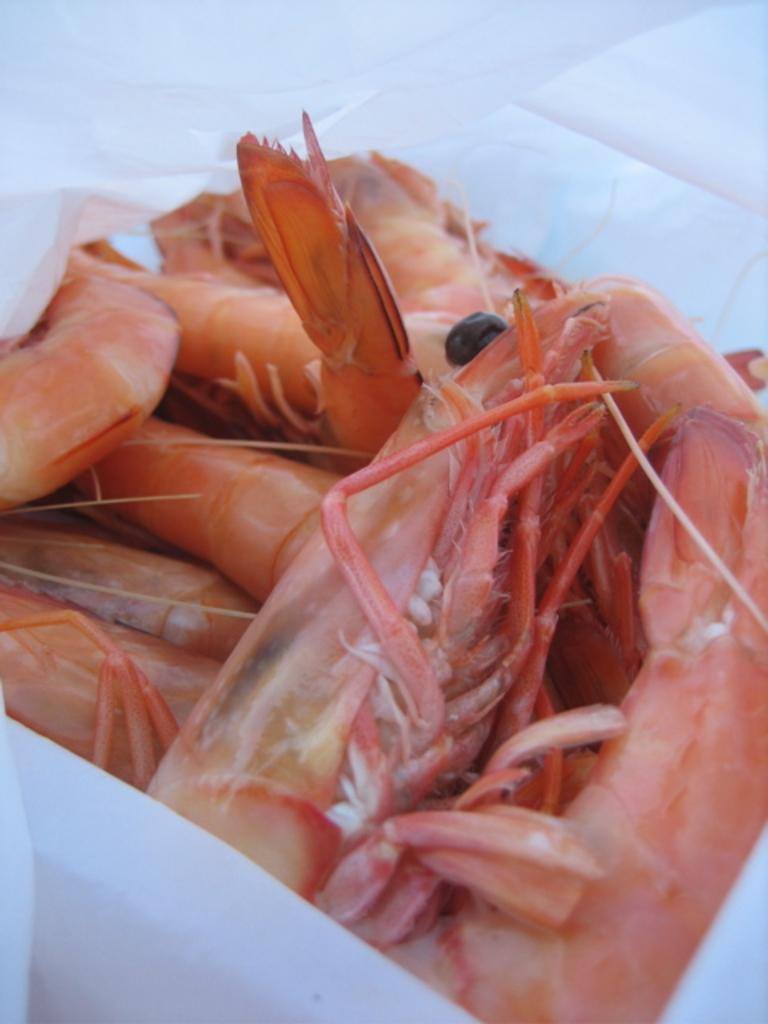What type of seafood is present in the image? There are prawns in the image. How are the prawns stored or contained in the image? The prawns are kept in a white color cover. What is the profit margin of the rail company in the image? There is no rail company or mention of profit in the image; it features prawns in a white color cover. 